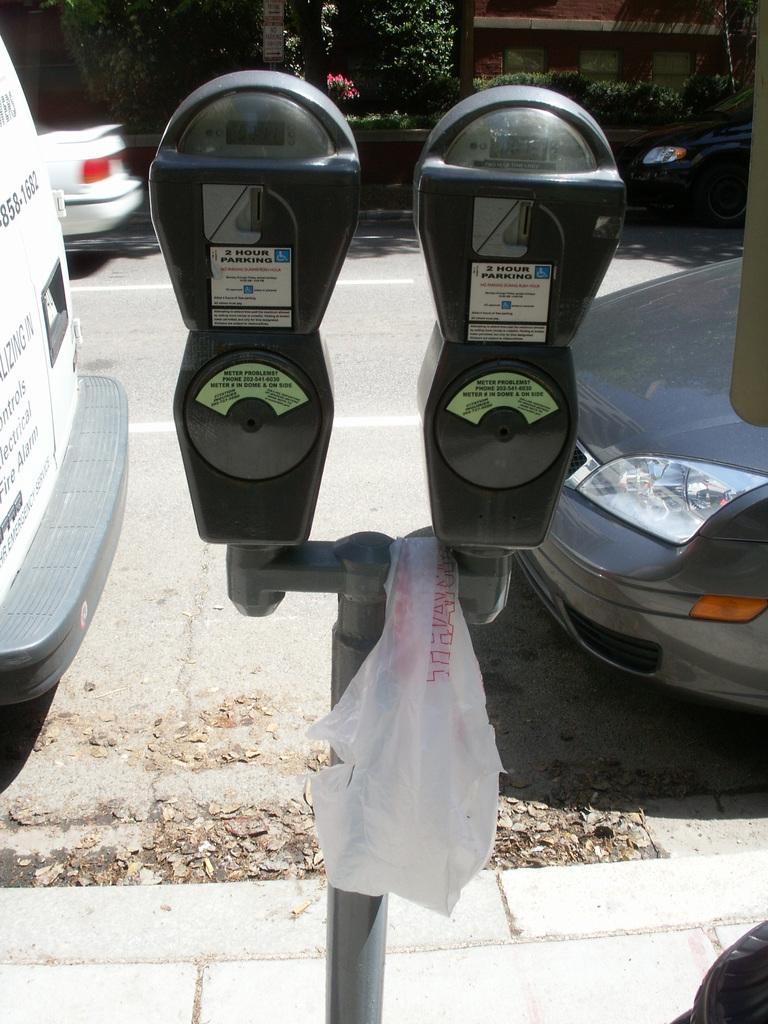What is written on the meter?
Offer a terse response. 2 hour parking. 